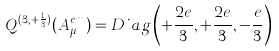Convert formula to latex. <formula><loc_0><loc_0><loc_500><loc_500>Q ^ { ( 3 , + \frac { 1 } { 3 } ) } ( A _ { \mu } ^ { e m } ) = D i a g \left ( + \frac { 2 e } { 3 } , + \frac { 2 e } { 3 } , - \frac { e } { 3 } \right )</formula> 